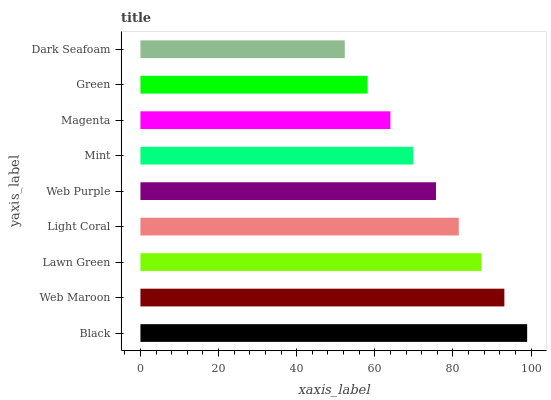Is Dark Seafoam the minimum?
Answer yes or no. Yes. Is Black the maximum?
Answer yes or no. Yes. Is Web Maroon the minimum?
Answer yes or no. No. Is Web Maroon the maximum?
Answer yes or no. No. Is Black greater than Web Maroon?
Answer yes or no. Yes. Is Web Maroon less than Black?
Answer yes or no. Yes. Is Web Maroon greater than Black?
Answer yes or no. No. Is Black less than Web Maroon?
Answer yes or no. No. Is Web Purple the high median?
Answer yes or no. Yes. Is Web Purple the low median?
Answer yes or no. Yes. Is Magenta the high median?
Answer yes or no. No. Is Web Maroon the low median?
Answer yes or no. No. 